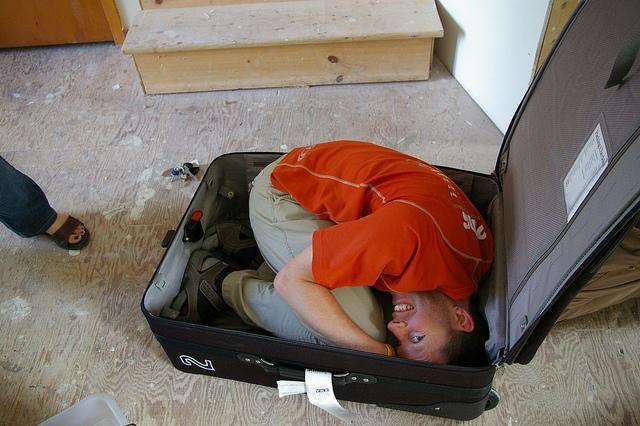How many people are there?
Give a very brief answer. 2. 